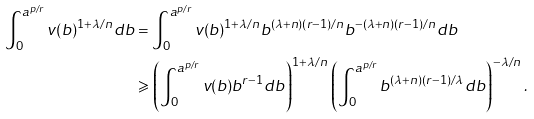<formula> <loc_0><loc_0><loc_500><loc_500>\int _ { 0 } ^ { a ^ { p / r } } v ( b ) ^ { 1 + \lambda / n } d b & = \int _ { 0 } ^ { a ^ { p / r } } v ( b ) ^ { 1 + \lambda / n } b ^ { ( \lambda + n ) ( r - 1 ) / n } b ^ { - ( \lambda + n ) ( r - 1 ) / n } d b \\ & \geqslant \left ( \int _ { 0 } ^ { a ^ { p / r } } v ( b ) b ^ { r - 1 } d b \right ) ^ { 1 + \lambda / n } \left ( \int _ { 0 } ^ { a ^ { p / r } } b ^ { ( \lambda + n ) ( r - 1 ) / \lambda } d b \right ) ^ { - \lambda / n } .</formula> 